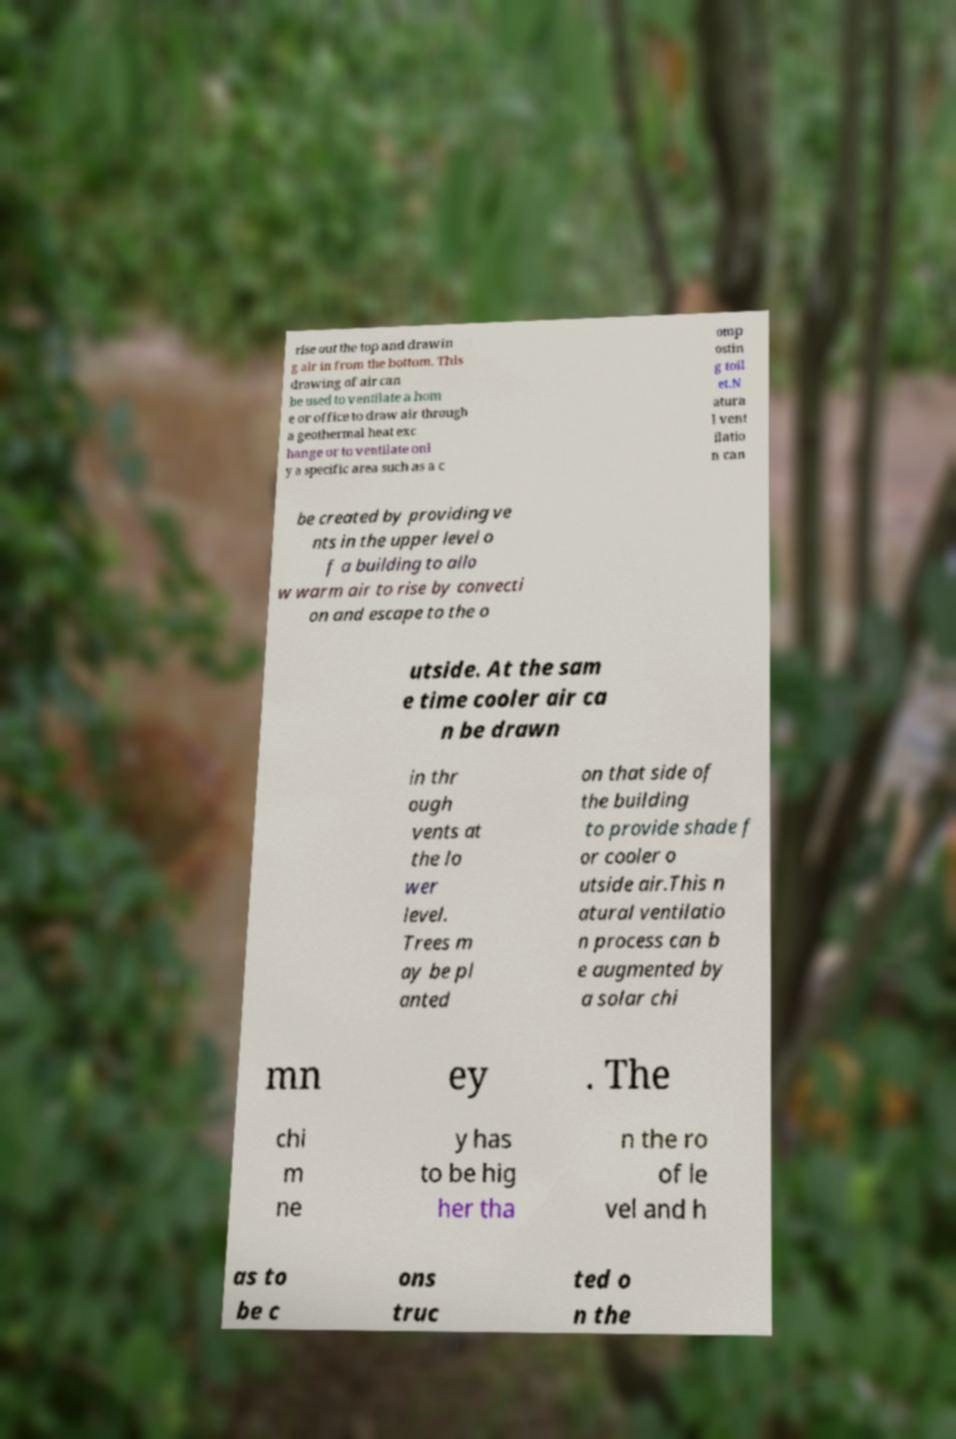Can you accurately transcribe the text from the provided image for me? rise out the top and drawin g air in from the bottom. This drawing of air can be used to ventilate a hom e or office to draw air through a geothermal heat exc hange or to ventilate onl y a specific area such as a c omp ostin g toil et.N atura l vent ilatio n can be created by providing ve nts in the upper level o f a building to allo w warm air to rise by convecti on and escape to the o utside. At the sam e time cooler air ca n be drawn in thr ough vents at the lo wer level. Trees m ay be pl anted on that side of the building to provide shade f or cooler o utside air.This n atural ventilatio n process can b e augmented by a solar chi mn ey . The chi m ne y has to be hig her tha n the ro of le vel and h as to be c ons truc ted o n the 